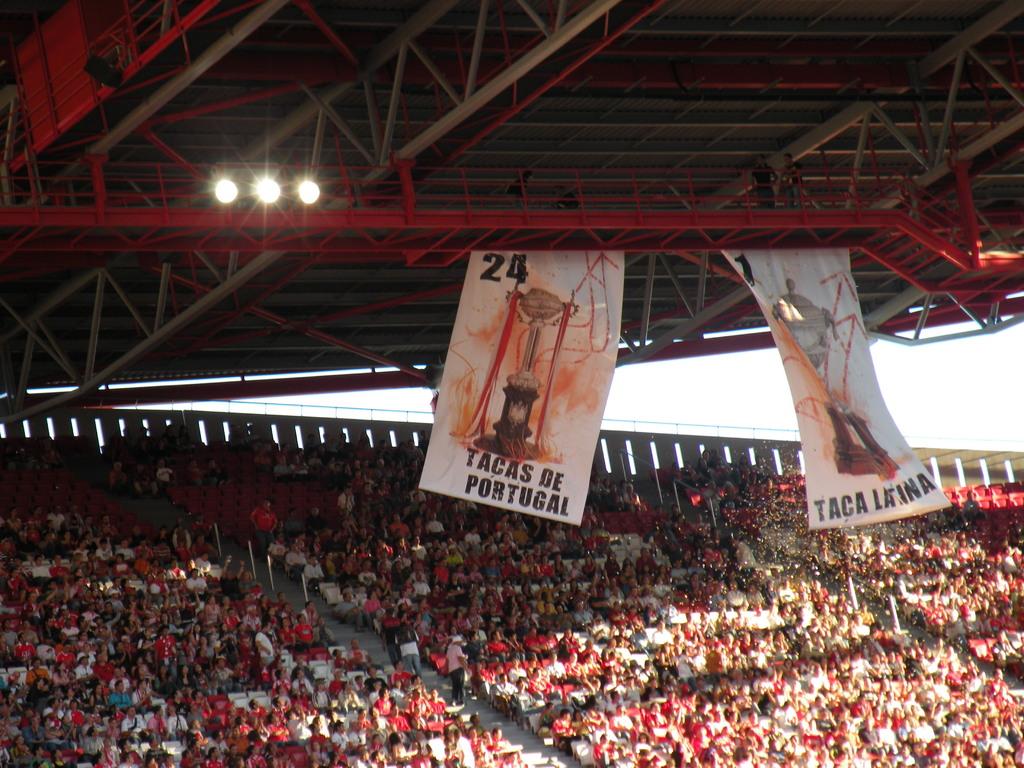What country is on the banner?
Provide a short and direct response. Portugal. What number is shown on the banner?
Offer a very short reply. 24. 